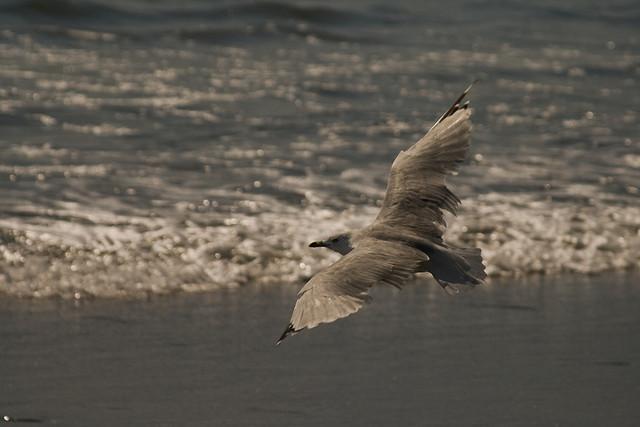How many people are visible in the room?
Give a very brief answer. 0. 